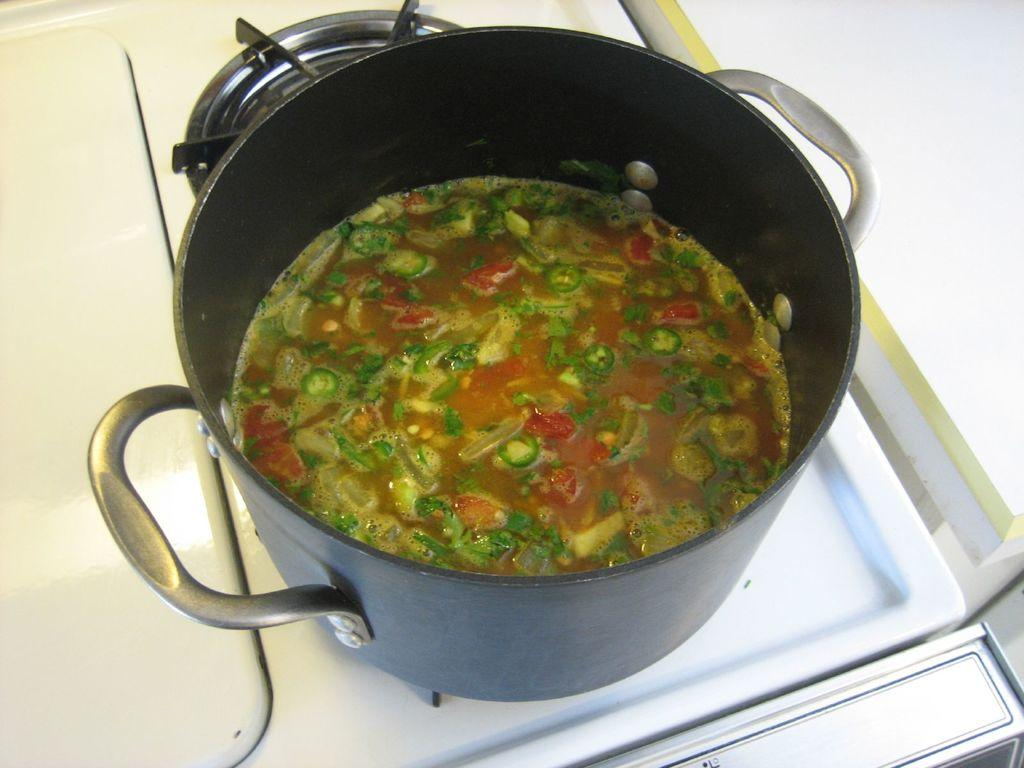What is on the stove in the image? There is a pan on the stove in the image. What is inside the pan? There is food in the pan. Can you describe the appearance of the food? The food is colorful. What color is the stove? The stove is white. How does the stove affect the direction of the food in the pan? The stove does not affect the direction of the food in the pan; it only provides heat for cooking. What type of stomach is visible in the image? There is no stomach present in the image. 